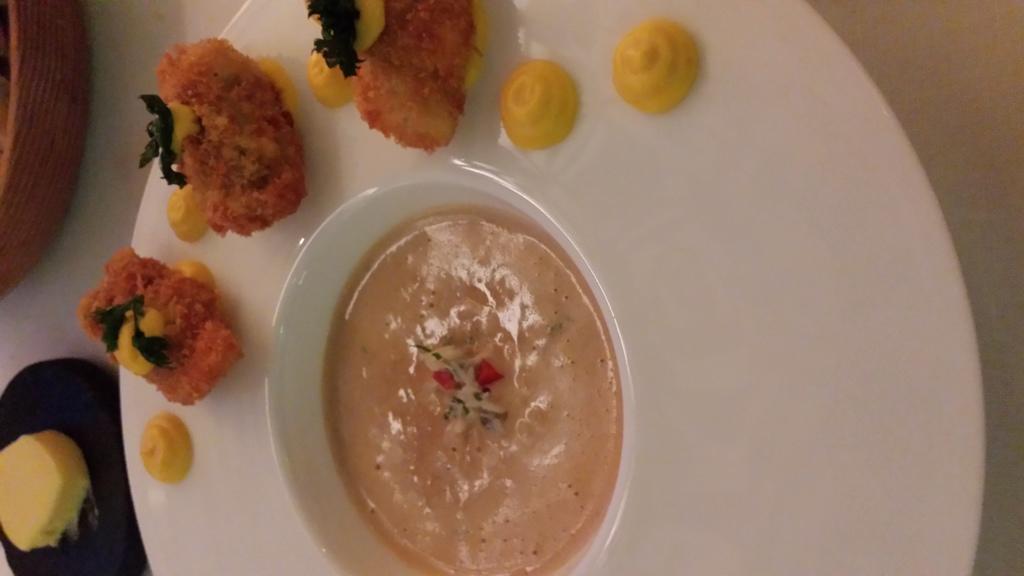In one or two sentences, can you explain what this image depicts? There is a plate with food items. On the plate there is a bowl with food items. And the plate is on a surface. Near to that there is a black object. On that something is there. 